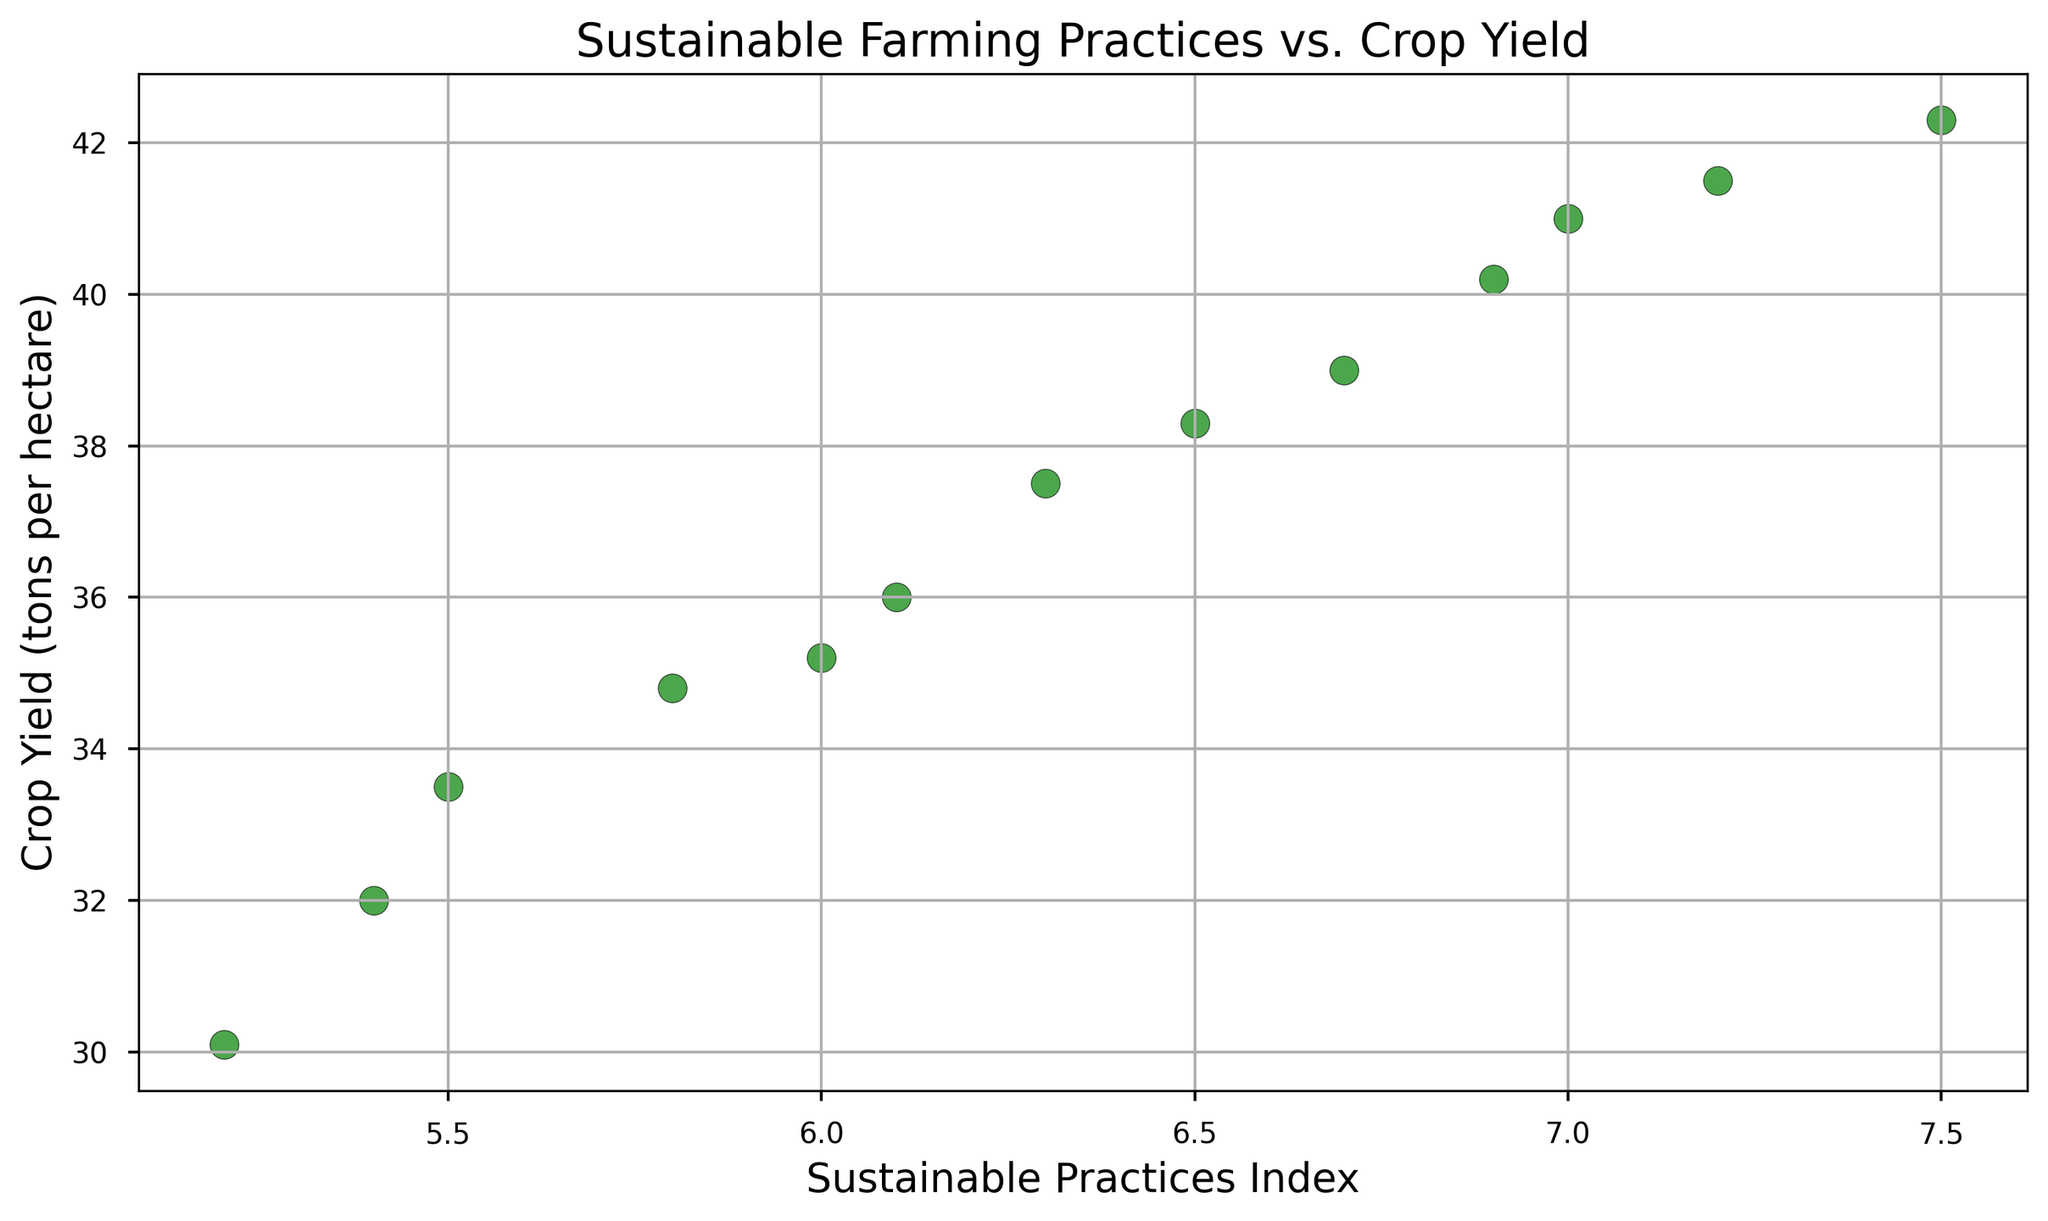What's the relationship between the Sustainable Practices Index and Crop Yield from 2010 to 2022? Start by observing the scatter plot's general trend. The points seem to form an upward-sloping pattern, indicating that as the Sustainable Practices Index increases, the Crop Yield also increases. This suggests a positive correlation between sustainable farming practices and crop yield.
Answer: Positive correlation What was the Crop Yield when the Sustainable Practices Index was 6.5? Locate the point on the x-axis corresponding to a Sustainable Practices Index of 6.5 and then check the corresponding value on the y-axis. The point indicates that the Crop Yield was around 38.3 tons per hectare.
Answer: 38.3 tons per hectare Did the Crop Yield increase consistently with the increase in the Sustainable Practices Index? Check the pattern of the points on the scatter plot. Each increase in the Sustainable Practices Index seems to be associated with an increase in Crop Yield, indicating a consistent upward trend without any significant drops or deviations.
Answer: Yes By how much did the Crop Yield increase from 2010 to 2022 as the Sustainable Practices Index changed? Look for the Crop Yield and Sustainable Practices Index in 2010 and 2022. In 2010, the Crop Yield was 30.1 tons per hectare, and in 2022, it was 42.3 tons per hectare. The increase in Crop Yield is 42.3 - 30.1 = 12.2 tons per hectare.
Answer: 12.2 tons per hectare What is the average Crop Yield over the years 2010 to 2022? Add up all the Crop Yield values from 2010 to 2022 and divide by the number of data points. The Crop Yield values are: 30.1, 32.0, 33.5, 34.8, 35.2, 36.0, 37.5, 38.3, 39.0, 40.2, 41.0, 41.5, and 42.3. Their sum is 441.4. There are 13 data points, so the average is 441.4 / 13 ≈ 33.95.
Answer: 33.95 tons per hectare Which year had the highest Crop Yield, and what was the corresponding Sustainable Practices Index? Identify the highest point on the y-axis and then check its corresponding x-axis value. The highest Crop Yield is 42.3 tons per hectare in 2022, with a corresponding Sustainable Practices Index of 7.5.
Answer: 2022, 7.5 How did the Sustainable Practices Index change from 2010 to 2022? Look at the points representing sustainable practices data on the x-axis from 2010 to 2022. There is a steady increase from 5.2 in 2010 to 7.5 in 2022.
Answer: Increased Compare the Crop Yield difference between the years with the lowest and highest Sustainable Practices Index. The lowest Sustainable Practices Index is 5.2 in 2010, with a Crop Yield of 30.1 tons per hectare. The highest is 7.5 in 2022, with a Crop Yield of 42.3 tons per hectare. The difference in Crop Yield is 42.3 - 30.1 = 12.2 tons per hectare.
Answer: 12.2 tons per hectare 